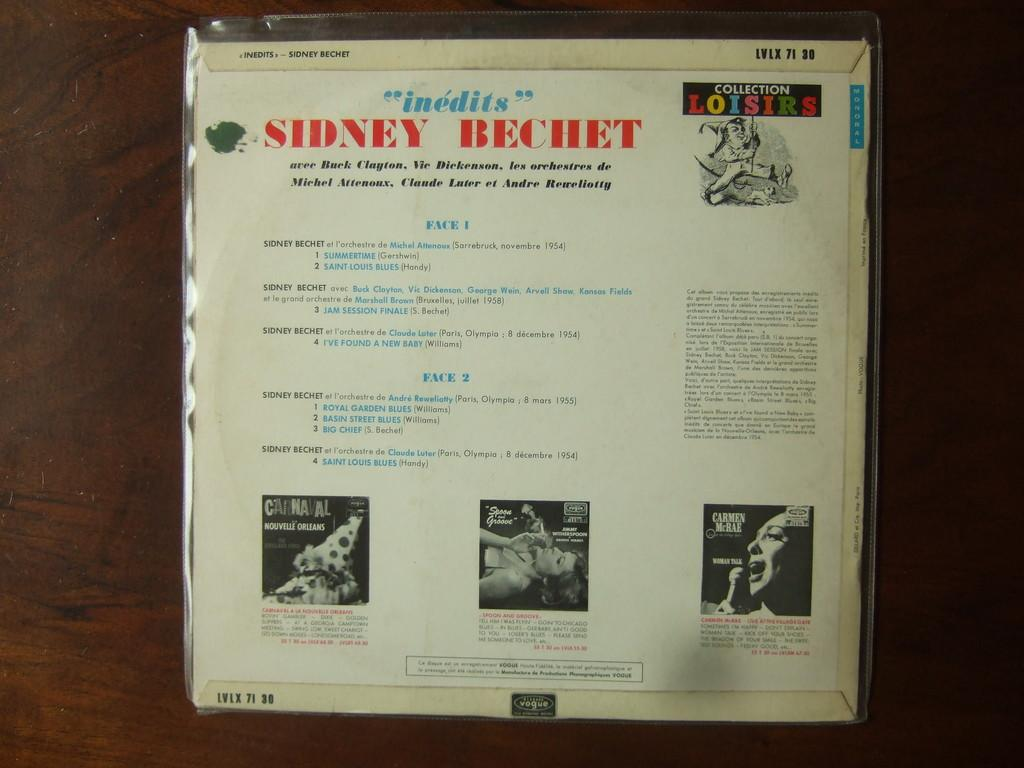<image>
Present a compact description of the photo's key features. The back of a package item has things such as SIdney Bechet listed on it. 